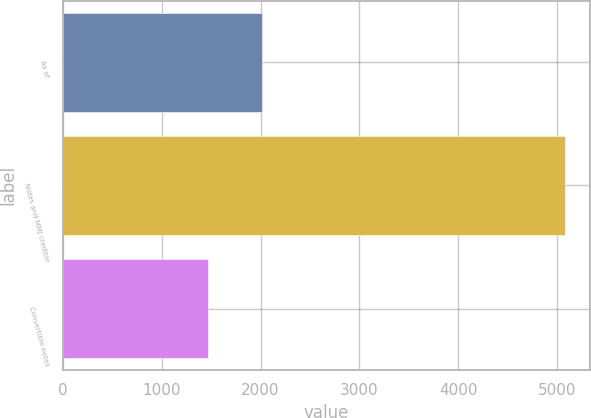Convert chart. <chart><loc_0><loc_0><loc_500><loc_500><bar_chart><fcel>As of<fcel>Notes and MMJ creditor<fcel>Convertible notes<nl><fcel>2015<fcel>5077<fcel>1472<nl></chart> 